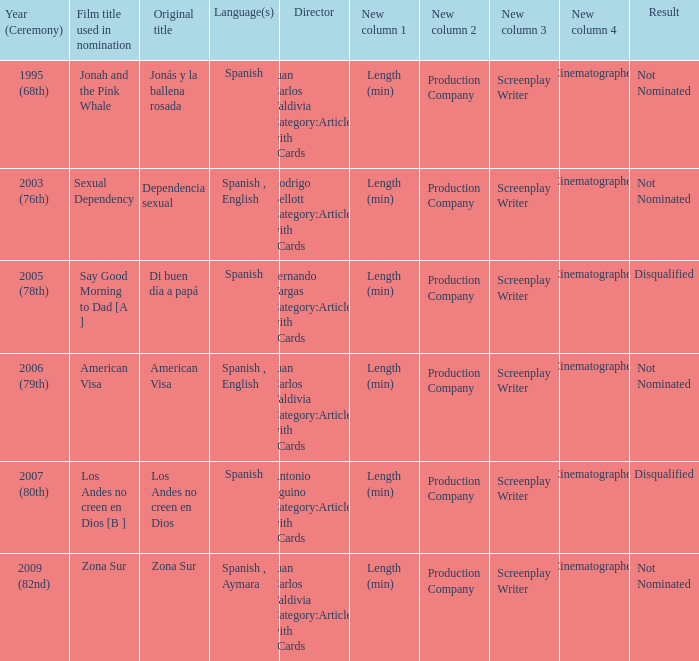In what year did zona sur receive a nomination? 2009 (82nd). 